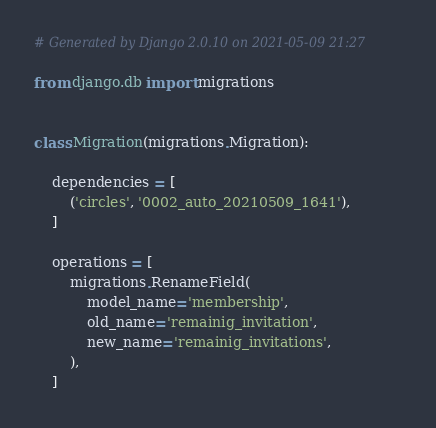Convert code to text. <code><loc_0><loc_0><loc_500><loc_500><_Python_># Generated by Django 2.0.10 on 2021-05-09 21:27

from django.db import migrations


class Migration(migrations.Migration):

    dependencies = [
        ('circles', '0002_auto_20210509_1641'),
    ]

    operations = [
        migrations.RenameField(
            model_name='membership',
            old_name='remainig_invitation',
            new_name='remainig_invitations',
        ),
    ]
</code> 